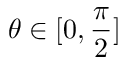<formula> <loc_0><loc_0><loc_500><loc_500>\theta \in [ 0 , \frac { \pi } { 2 } ]</formula> 